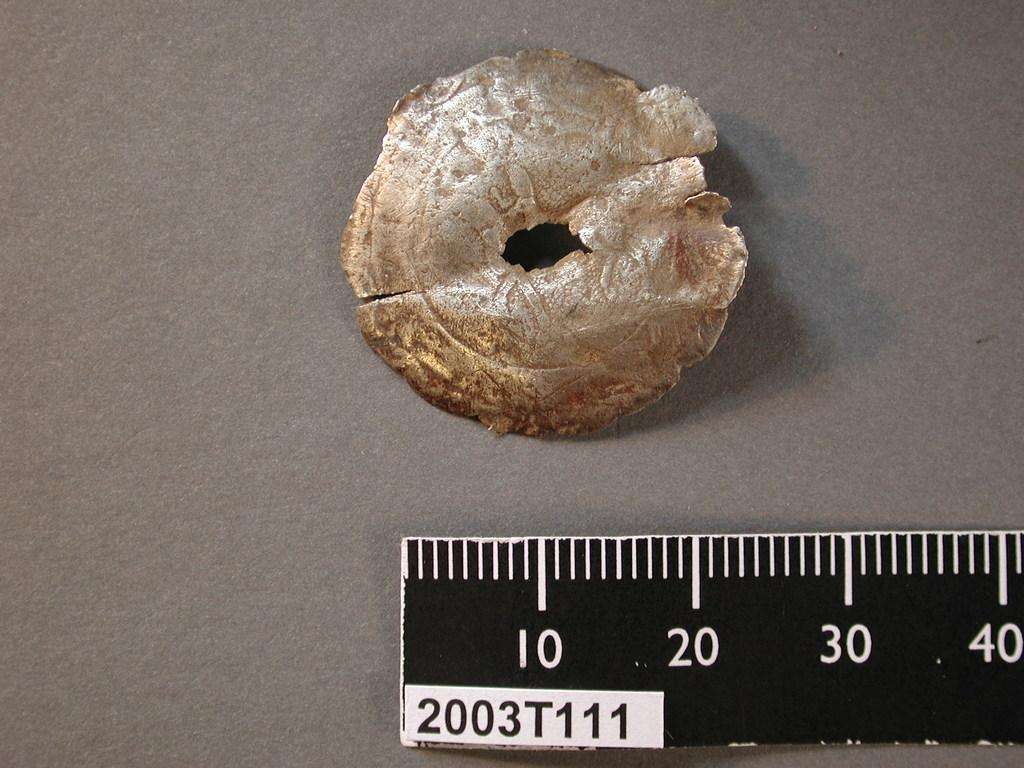<image>
Share a concise interpretation of the image provided. a ruler with the numbers 10 to 40 shown 